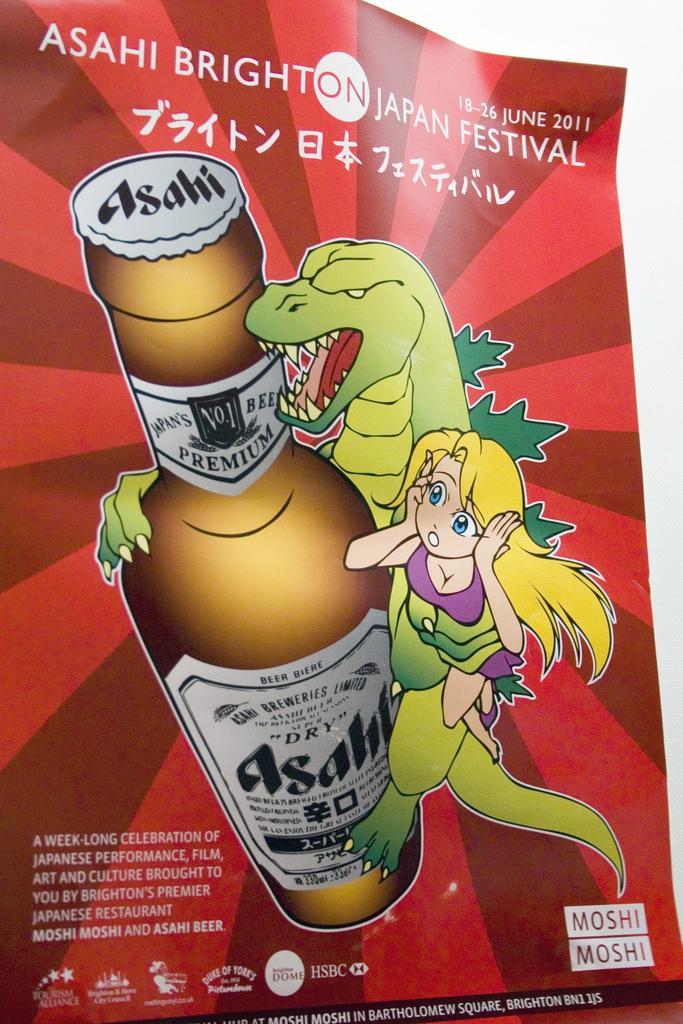Describe this image in one or two sentences. In this picture I can see a paper on an object, there are logos, words, numbers and there is a picture on the paper. 